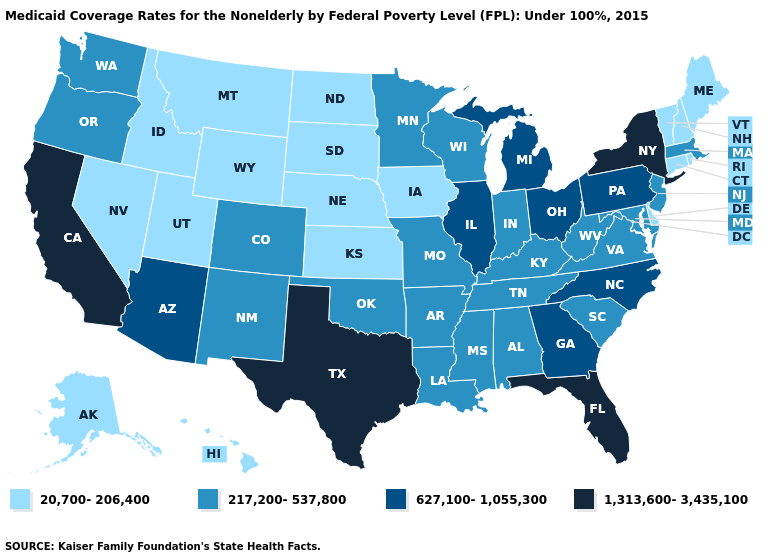What is the value of Alaska?
Keep it brief. 20,700-206,400. How many symbols are there in the legend?
Short answer required. 4. What is the value of Delaware?
Concise answer only. 20,700-206,400. Does California have the highest value in the West?
Answer briefly. Yes. Does Oregon have the same value as Illinois?
Be succinct. No. How many symbols are there in the legend?
Keep it brief. 4. Name the states that have a value in the range 627,100-1,055,300?
Keep it brief. Arizona, Georgia, Illinois, Michigan, North Carolina, Ohio, Pennsylvania. What is the value of Hawaii?
Give a very brief answer. 20,700-206,400. Does the first symbol in the legend represent the smallest category?
Keep it brief. Yes. What is the value of California?
Concise answer only. 1,313,600-3,435,100. What is the value of Florida?
Write a very short answer. 1,313,600-3,435,100. Which states have the lowest value in the West?
Keep it brief. Alaska, Hawaii, Idaho, Montana, Nevada, Utah, Wyoming. Does the map have missing data?
Short answer required. No. Name the states that have a value in the range 1,313,600-3,435,100?
Concise answer only. California, Florida, New York, Texas. 